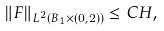<formula> <loc_0><loc_0><loc_500><loc_500>\left \| F \right \| _ { L ^ { 2 } \left ( B _ { 1 } \times \left ( 0 , 2 \right ) \right ) } \leq C H ,</formula> 